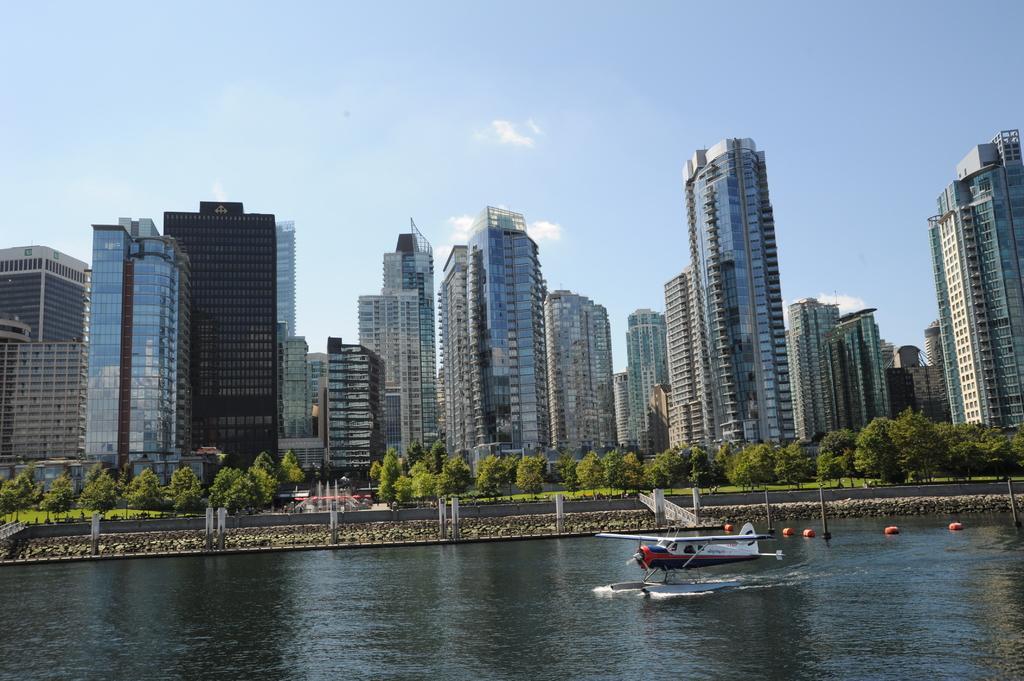Please provide a concise description of this image. In this image in front there is a helicopter in the water. At the center of the image there is a bridge. In the background there are trees, buildings and sky. 